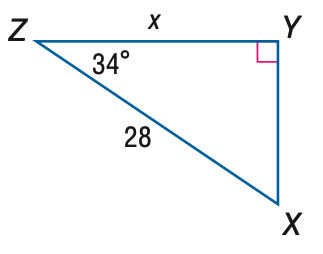Answer the mathemtical geometry problem and directly provide the correct option letter.
Question: Find x. Round to the nearest tenth.
Choices: A: 15.7 B: 18.9 C: 23.2 D: 33.8 C 